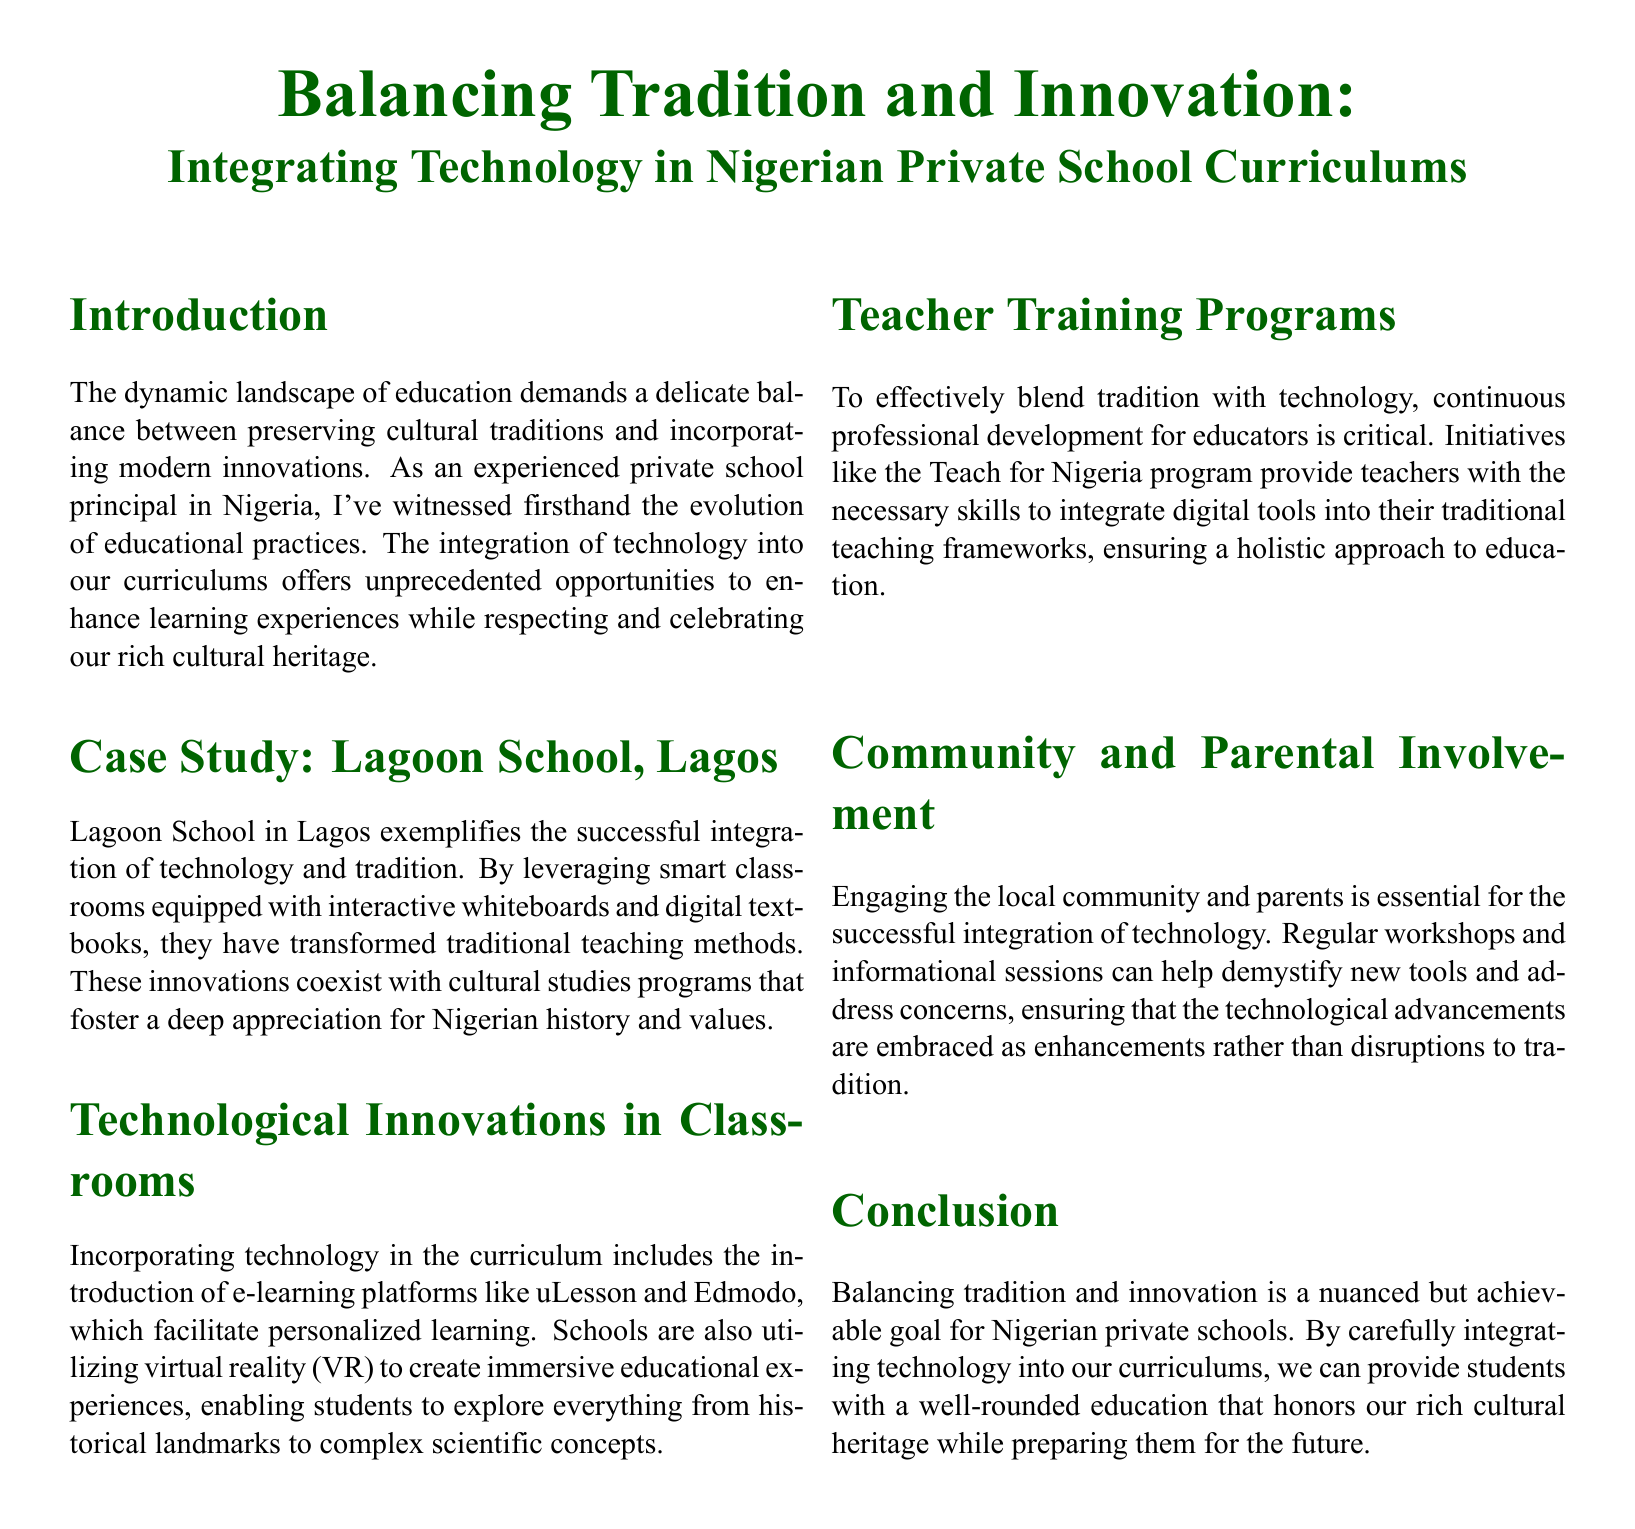What is the title of the document? The title of the document is prominently displayed at the top, presenting the main theme.
Answer: Balancing Tradition and Innovation: Integrating Technology in Nigerian Private School Curriculums Which school serves as a case study in Lagos? The document mentions a specific school to showcase successful integration of technology and tradition.
Answer: Lagoon School What e-learning platforms are mentioned in the document? The document lists specific e-learning platforms that are utilized in the curriculum for personalized learning.
Answer: uLesson and Edmodo What type of training program is highlighted for teachers? The document describes a specific program aimed at enhancing teachers' integration of technology.
Answer: Teach for Nigeria How many visual case studies are listed? The document enumerates various visual case studies related to technology integration, indicating the total count.
Answer: Four What is the color of the box highlighting the Visual Case Studies? The document specifies the color of the box used to present visual case studies, representing the aesthetic choices in the layout.
Answer: Light green What method is suggested for community involvement? The document recommends a specific method for involving community and parents in the technological advancements at schools.
Answer: Workshops What is the balance that Nigerian private schools are striving for? The conclusion summarizes the key objective for educational institutions highlighted throughout the document.
Answer: Tradition and innovation 